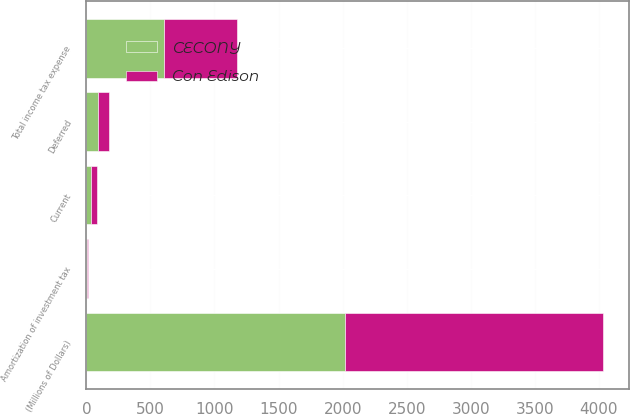Convert chart. <chart><loc_0><loc_0><loc_500><loc_500><stacked_bar_chart><ecel><fcel>(Millions of Dollars)<fcel>Current<fcel>Deferred<fcel>Amortization of investment tax<fcel>Total income tax expense<nl><fcel>CECONY<fcel>2015<fcel>38<fcel>93<fcel>9<fcel>605<nl><fcel>Con Edison<fcel>2015<fcel>48<fcel>82<fcel>5<fcel>574<nl></chart> 